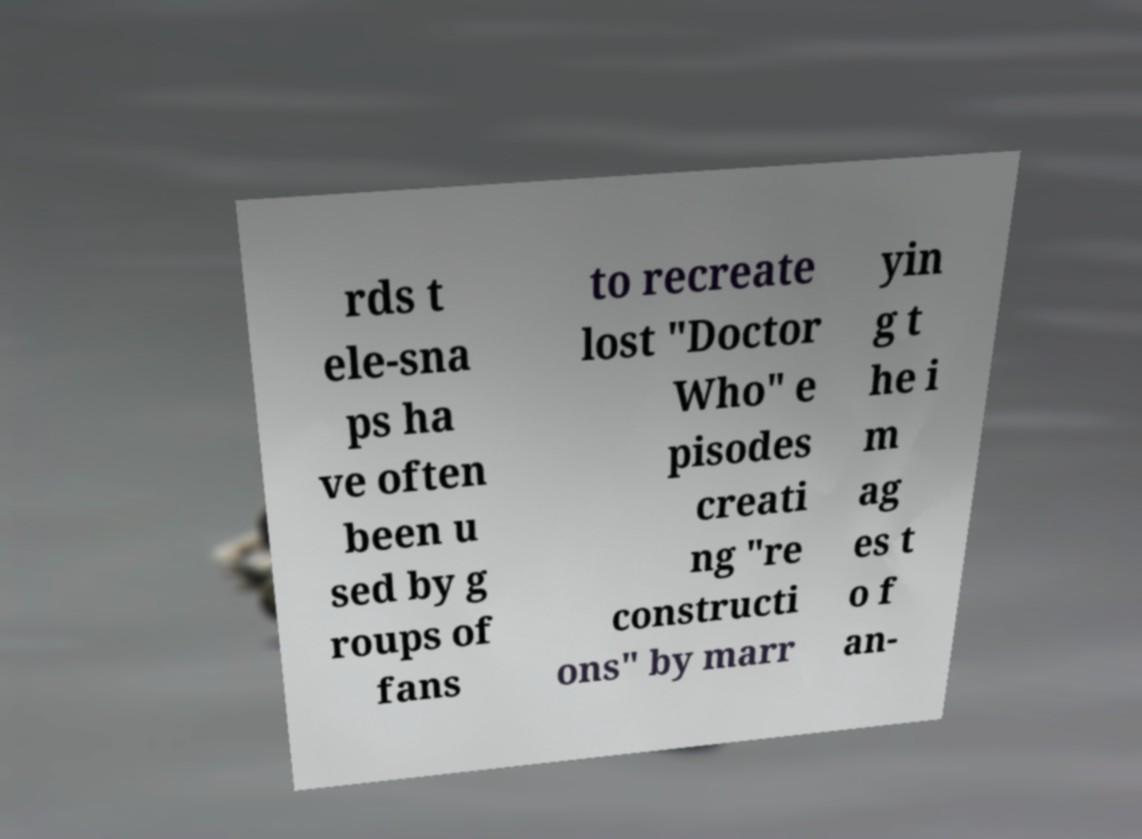For documentation purposes, I need the text within this image transcribed. Could you provide that? rds t ele-sna ps ha ve often been u sed by g roups of fans to recreate lost "Doctor Who" e pisodes creati ng "re constructi ons" by marr yin g t he i m ag es t o f an- 